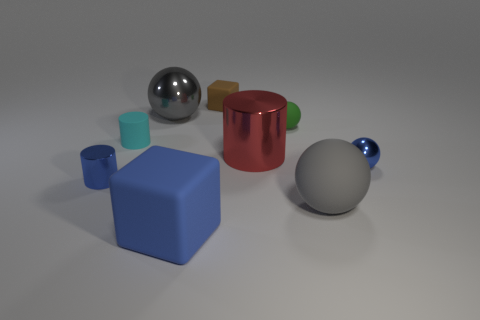Subtract all spheres. How many objects are left? 5 Subtract 0 cyan balls. How many objects are left? 9 Subtract all tiny gray metallic cubes. Subtract all big objects. How many objects are left? 5 Add 3 brown objects. How many brown objects are left? 4 Add 4 metallic balls. How many metallic balls exist? 6 